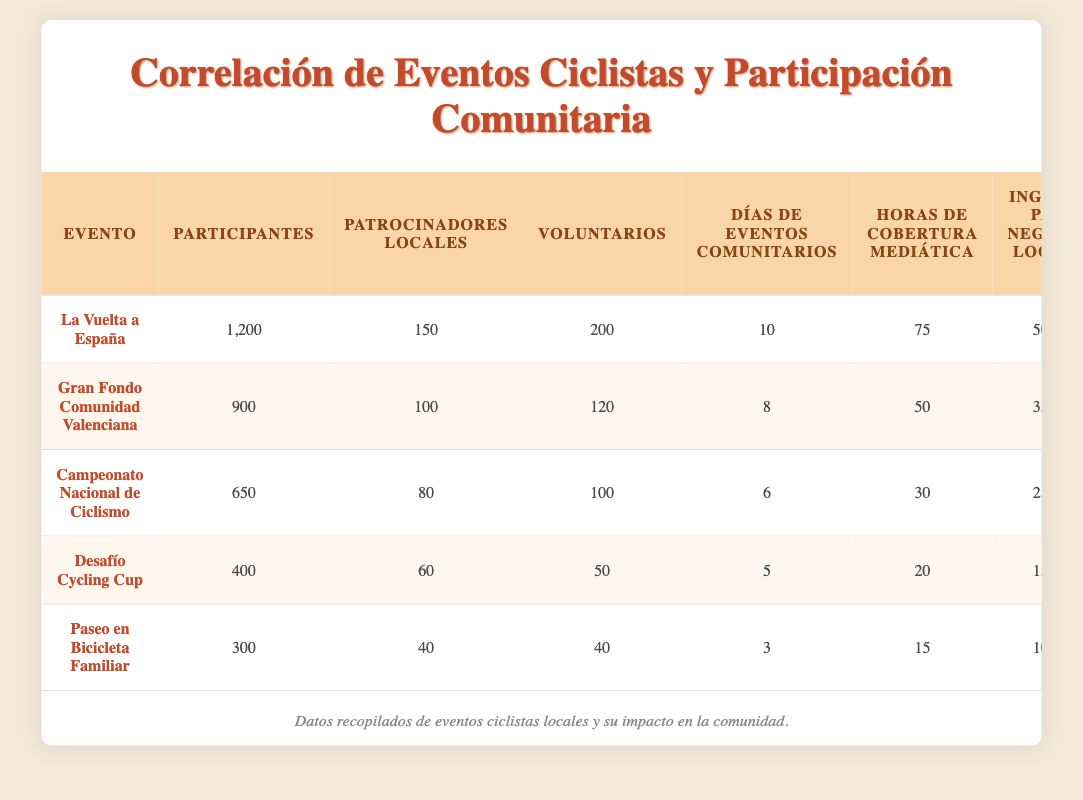What is the maximum number of participants for a single cycling event? The maximum number of participants can be found by looking at the "Participantes" column. Scanning through the rows, we see that "La Vuelta a España" has the highest value at 1,200 participants.
Answer: 1200 How many local sponsors were present for the "Gran Fondo Comunidad Valenciana"? The number of local sponsors for "Gran Fondo Comunidad Valenciana" is stated directly in the table under the "Patrocinadores Locales" column, which shows a value of 100.
Answer: 100 What is the total number of volunteers across all events? To find the total number of volunteers, we add the "Voluntarios" values from each event: 200 + 120 + 100 + 50 + 40 = 610. Hence, the total number of volunteers is 610.
Answer: 610 Is the media coverage for the "Desafío Cycling Cup" greater than the coverage for "Paseo en Bicicleta Familiar"? We compare the "Horas de Cobertura Mediática" for both events. "Desafío Cycling Cup" has 20 hours, while "Paseo en Bicicleta Familiar" has 15 hours. Since 20 is greater than 15, the statement is true.
Answer: Yes What is the average local business income among the events? To calculate the average local business income, we first sum the values: 50000 + 35000 + 25000 + 15000 + 10000 = 135000. Then, we divide by the number of events (5): 135000 / 5 = 27000. Therefore, the average income is 27000 euros.
Answer: 27000 How many community event days did the event with the highest local business income have? The event with the highest local business income is "La Vuelta a España" with €50,000. Looking at the "Días de Eventos Comunitarios" column, we see it has 10 days.
Answer: 10 Which event had the least participation and what was the income generated by local businesses during that event? Scanning through the "Participantes" column shows that "Paseo en Bicicleta Familiar" has the least participation at 300. Checking the "Ingresos para Negocios Locales" column reveals an income of €10,000 for this event.
Answer: 10000 What is the difference in the number of local sponsors between "La Vuelta a España" and "Desafío Cycling Cup"? We find the number of local sponsors for both events. "La Vuelta a España" has 150 local sponsors while "Desafío Cycling Cup" has 60. The difference is thus: 150 - 60 = 90.
Answer: 90 What percentage of volunteers participated in "Gran Fondo Comunidad Valenciana" compared to "La Vuelta a España"? For "Gran Fondo Comunidad Valenciana", there were 120 volunteers, and for "La Vuelta a España" there were 200 volunteers. To calculate the percentage: (120 / 200) * 100 = 60%. Thus, 60% of "La Vuelta a España" volunteers were involved in "Gran Fondo Comunidad Valenciana".
Answer: 60% 